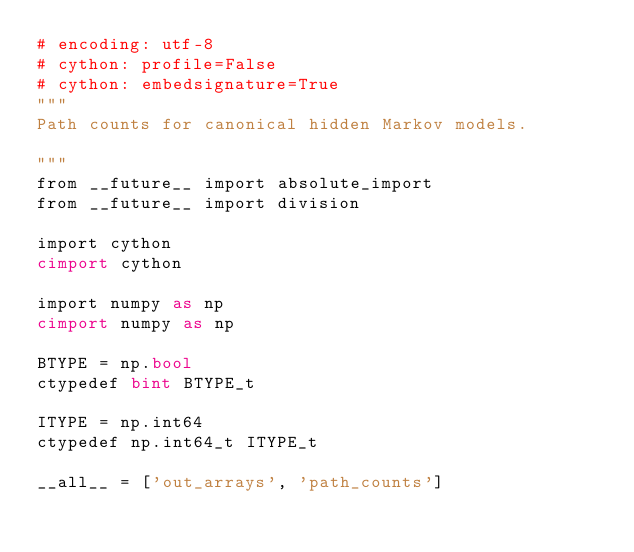Convert code to text. <code><loc_0><loc_0><loc_500><loc_500><_Cython_># encoding: utf-8
# cython: profile=False
# cython: embedsignature=True
"""
Path counts for canonical hidden Markov models.

"""
from __future__ import absolute_import
from __future__ import division

import cython
cimport cython

import numpy as np
cimport numpy as np

BTYPE = np.bool
ctypedef bint BTYPE_t

ITYPE = np.int64
ctypedef np.int64_t ITYPE_t

__all__ = ['out_arrays', 'path_counts']
</code> 